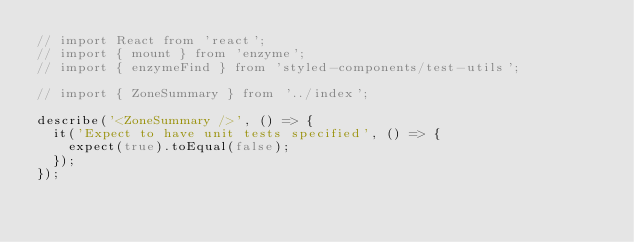<code> <loc_0><loc_0><loc_500><loc_500><_JavaScript_>// import React from 'react';
// import { mount } from 'enzyme';
// import { enzymeFind } from 'styled-components/test-utils';

// import { ZoneSummary } from '../index';

describe('<ZoneSummary />', () => {
  it('Expect to have unit tests specified', () => {
    expect(true).toEqual(false);
  });
});
</code> 